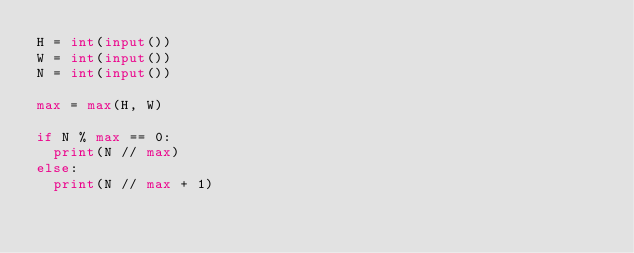Convert code to text. <code><loc_0><loc_0><loc_500><loc_500><_Python_>H = int(input())
W = int(input())
N = int(input())

max = max(H, W)

if N % max == 0:
  print(N // max)
else:
  print(N // max + 1)</code> 